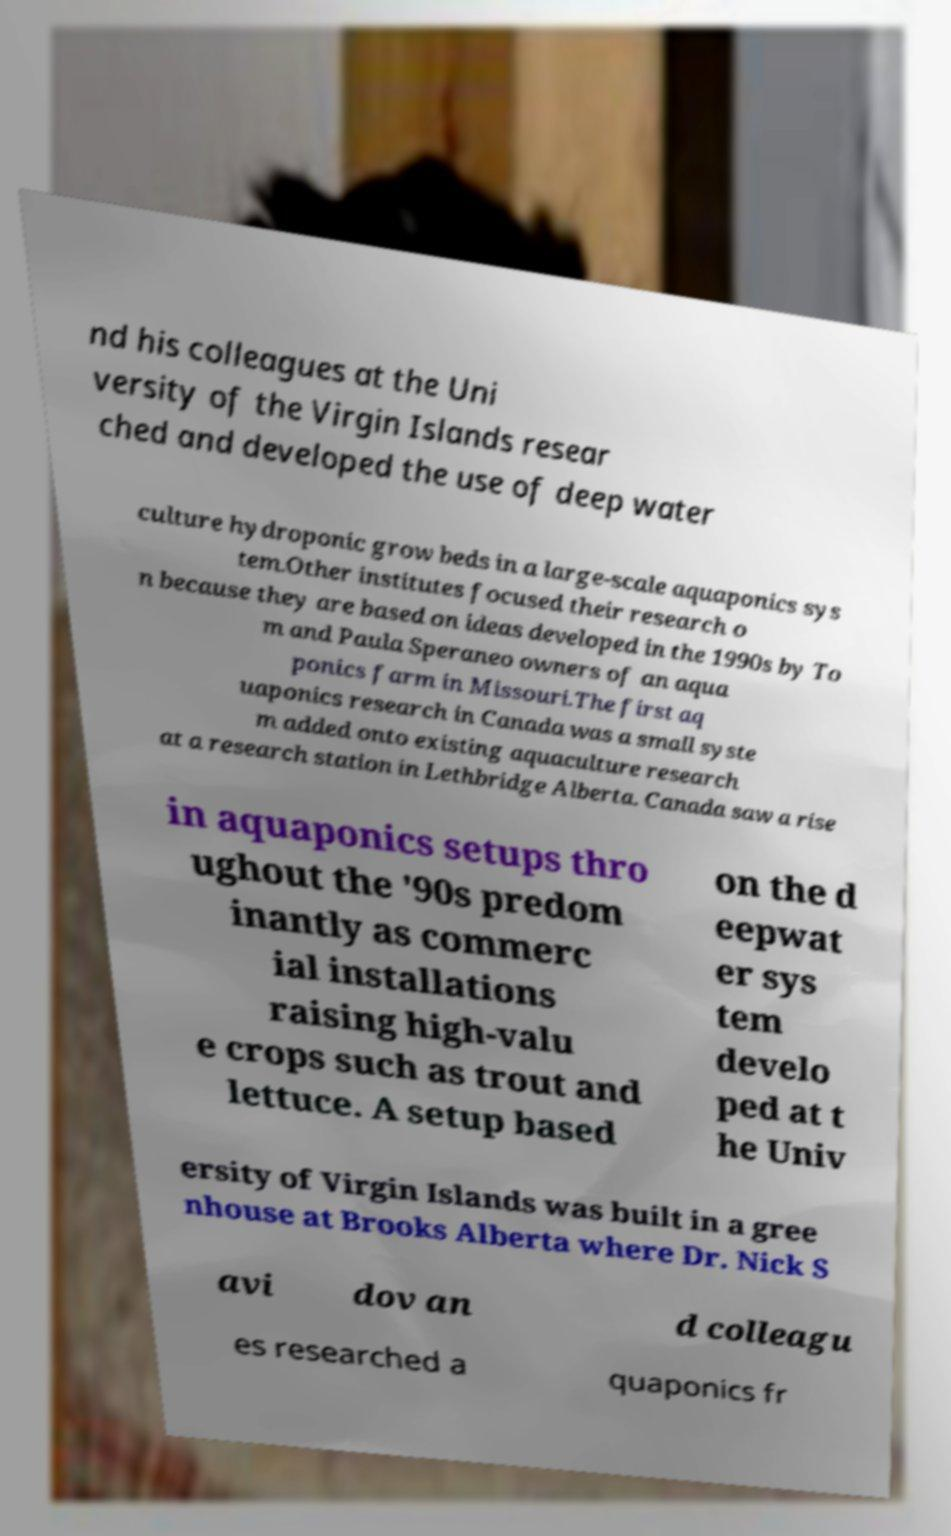Please identify and transcribe the text found in this image. nd his colleagues at the Uni versity of the Virgin Islands resear ched and developed the use of deep water culture hydroponic grow beds in a large-scale aquaponics sys tem.Other institutes focused their research o n because they are based on ideas developed in the 1990s by To m and Paula Speraneo owners of an aqua ponics farm in Missouri.The first aq uaponics research in Canada was a small syste m added onto existing aquaculture research at a research station in Lethbridge Alberta. Canada saw a rise in aquaponics setups thro ughout the '90s predom inantly as commerc ial installations raising high-valu e crops such as trout and lettuce. A setup based on the d eepwat er sys tem develo ped at t he Univ ersity of Virgin Islands was built in a gree nhouse at Brooks Alberta where Dr. Nick S avi dov an d colleagu es researched a quaponics fr 